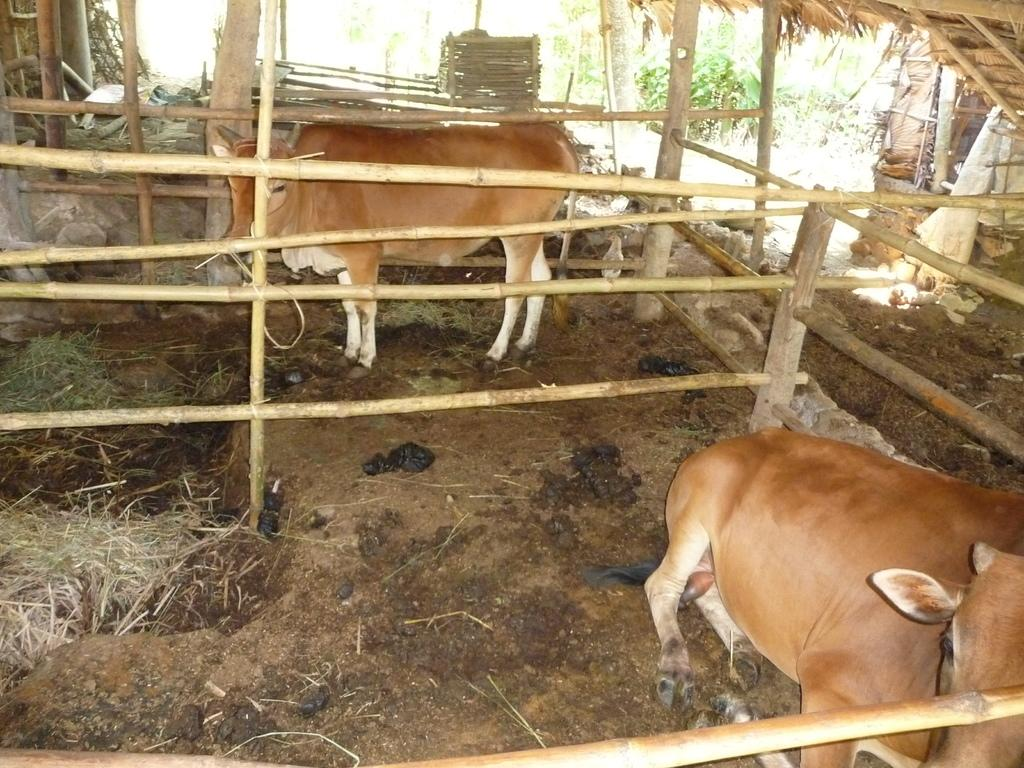What animals can be seen on the ground in the image? There are cows on the ground in the image. What type of objects are made of wood in the image? There are wooden objects in the image. What type of vegetation is present in the image? There are plants and grass in the image. What can be found on the ground along with the cows? There is dung on the ground in the image. What type of fold can be seen in the image? There is no fold present in the image. Can you describe the sidewalk in the image? There is no sidewalk present in the image. 